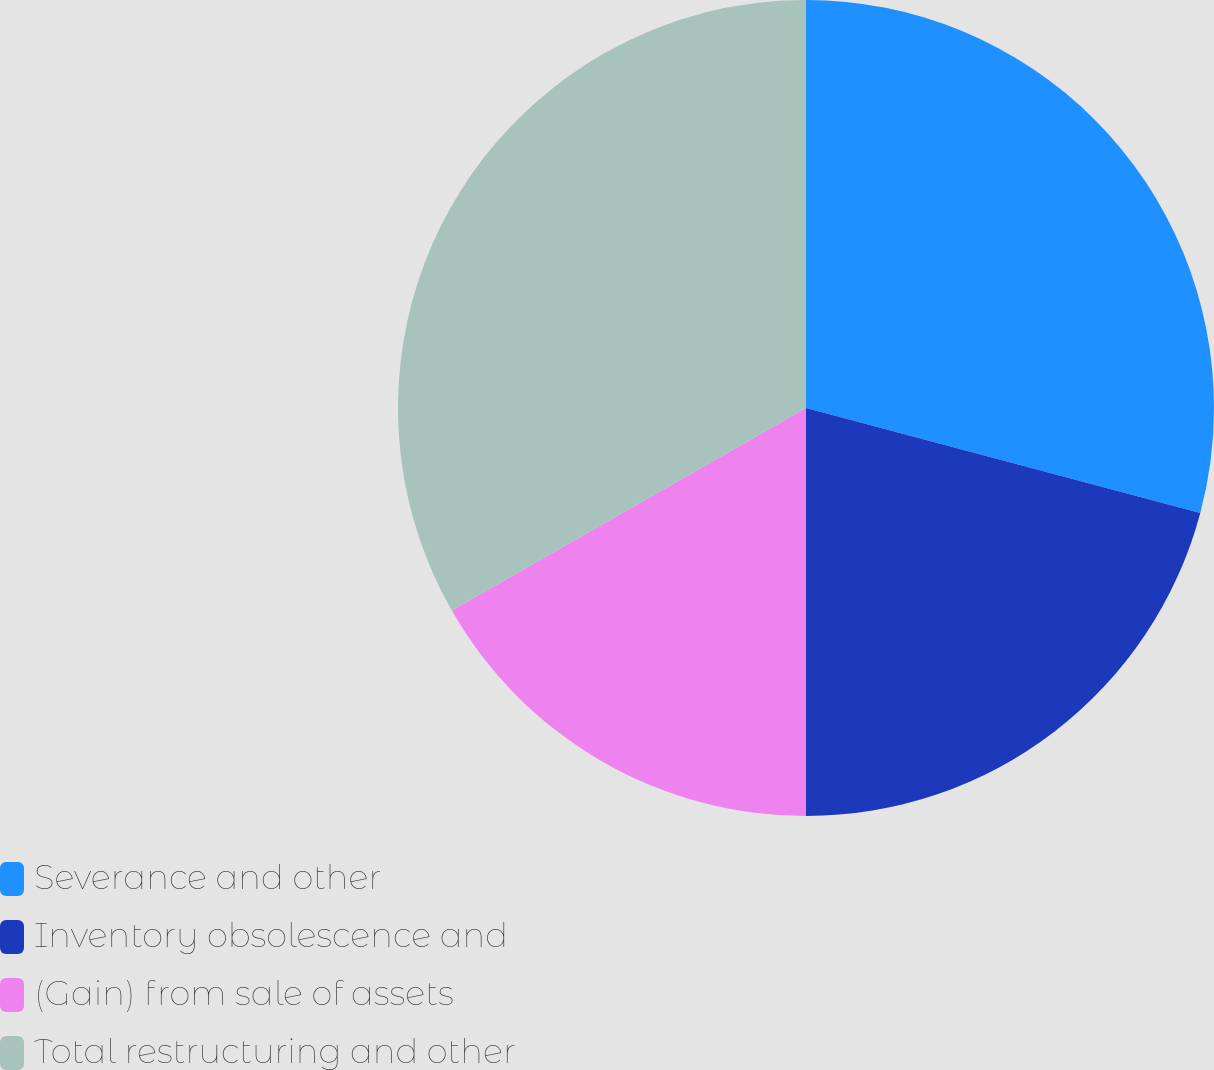Convert chart to OTSL. <chart><loc_0><loc_0><loc_500><loc_500><pie_chart><fcel>Severance and other<fcel>Inventory obsolescence and<fcel>(Gain) from sale of assets<fcel>Total restructuring and other<nl><fcel>29.14%<fcel>20.86%<fcel>16.73%<fcel>33.27%<nl></chart> 